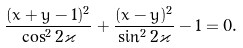Convert formula to latex. <formula><loc_0><loc_0><loc_500><loc_500>\frac { ( x + y - 1 ) ^ { 2 } } { \cos ^ { 2 } 2 \varkappa } + \frac { ( x - y ) ^ { 2 } } { \sin ^ { 2 } 2 \varkappa } - 1 = 0 .</formula> 